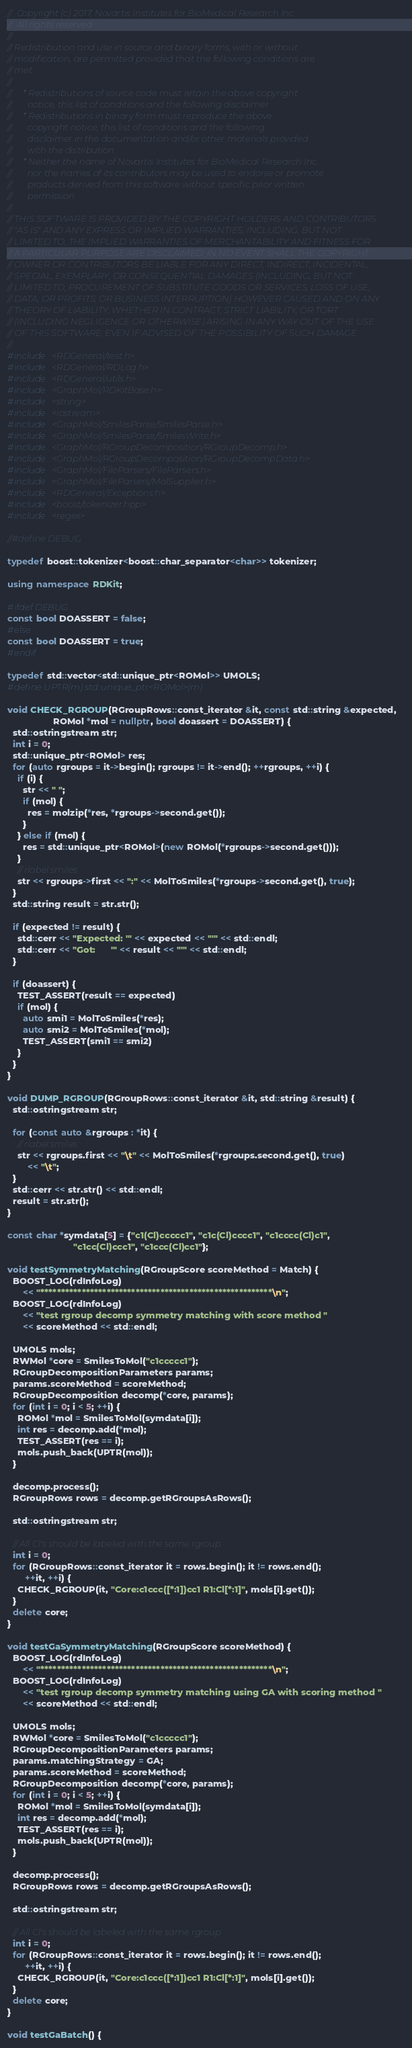Convert code to text. <code><loc_0><loc_0><loc_500><loc_500><_C++_>//  Copyright (c) 2017, Novartis Institutes for BioMedical Research Inc.
//  All rights reserved.
//
// Redistribution and use in source and binary forms, with or without
// modification, are permitted provided that the following conditions are
// met:
//
//     * Redistributions of source code must retain the above copyright
//       notice, this list of conditions and the following disclaimer.
//     * Redistributions in binary form must reproduce the above
//       copyright notice, this list of conditions and the following
//       disclaimer in the documentation and/or other materials provided
//       with the distribution.
//     * Neither the name of Novartis Institutes for BioMedical Research Inc.
//       nor the names of its contributors may be used to endorse or promote
//       products derived from this software without specific prior written
//       permission.
//
// THIS SOFTWARE IS PROVIDED BY THE COPYRIGHT HOLDERS AND CONTRIBUTORS
// "AS IS" AND ANY EXPRESS OR IMPLIED WARRANTIES, INCLUDING, BUT NOT
// LIMITED TO, THE IMPLIED WARRANTIES OF MERCHANTABILITY AND FITNESS FOR
// A PARTICULAR PURPOSE ARE DISCLAIMED. IN NO EVENT SHALL THE COPYRIGHT
// OWNER OR CONTRIBUTORS BE LIABLE FOR ANY DIRECT, INDIRECT, INCIDENTAL,
// SPECIAL, EXEMPLARY, OR CONSEQUENTIAL DAMAGES (INCLUDING, BUT NOT
// LIMITED TO, PROCUREMENT OF SUBSTITUTE GOODS OR SERVICES; LOSS OF USE,
// DATA, OR PROFITS; OR BUSINESS INTERRUPTION) HOWEVER CAUSED AND ON ANY
// THEORY OF LIABILITY, WHETHER IN CONTRACT, STRICT LIABILITY, OR TORT
// (INCLUDING NEGLIGENCE OR OTHERWISE) ARISING IN ANY WAY OUT OF THE USE
// OF THIS SOFTWARE, EVEN IF ADVISED OF THE POSSIBILITY OF SUCH DAMAGE.
//
#include <RDGeneral/test.h>
#include <RDGeneral/RDLog.h>
#include <RDGeneral/utils.h>
#include <GraphMol/RDKitBase.h>
#include <string>
#include <iostream>
#include <GraphMol/SmilesParse/SmilesParse.h>
#include <GraphMol/SmilesParse/SmilesWrite.h>
#include <GraphMol/RGroupDecomposition/RGroupDecomp.h>
#include <GraphMol/RGroupDecomposition/RGroupDecompData.h>
#include <GraphMol/FileParsers/FileParsers.h>
#include <GraphMol/FileParsers/MolSupplier.h>
#include <RDGeneral/Exceptions.h>
#include <boost/tokenizer.hpp>
#include <regex>

//#define DEBUG

typedef boost::tokenizer<boost::char_separator<char>> tokenizer;

using namespace RDKit;

#ifdef DEBUG
const bool DOASSERT = false;
#else
const bool DOASSERT = true;
#endif

typedef std::vector<std::unique_ptr<ROMol>> UMOLS;
#define UPTR(m) std::unique_ptr<ROMol>(m)

void CHECK_RGROUP(RGroupRows::const_iterator &it, const std::string &expected,
                  ROMol *mol = nullptr, bool doassert = DOASSERT) {
  std::ostringstream str;
  int i = 0;
  std::unique_ptr<ROMol> res;
  for (auto rgroups = it->begin(); rgroups != it->end(); ++rgroups, ++i) {
    if (i) {
      str << " ";
      if (mol) {
        res = molzip(*res, *rgroups->second.get());
      }
    } else if (mol) {
      res = std::unique_ptr<ROMol>(new ROMol(*rgroups->second.get()));
    }
    // rlabel:smiles
    str << rgroups->first << ":" << MolToSmiles(*rgroups->second.get(), true);
  }
  std::string result = str.str();

  if (expected != result) {
    std::cerr << "Expected: '" << expected << "'" << std::endl;
    std::cerr << "Got:      '" << result << "'" << std::endl;
  }

  if (doassert) {
    TEST_ASSERT(result == expected)
    if (mol) {
      auto smi1 = MolToSmiles(*res);
      auto smi2 = MolToSmiles(*mol);
      TEST_ASSERT(smi1 == smi2)
    }
  }
}

void DUMP_RGROUP(RGroupRows::const_iterator &it, std::string &result) {
  std::ostringstream str;

  for (const auto &rgroups : *it) {
    // rlabel:smiles
    str << rgroups.first << "\t" << MolToSmiles(*rgroups.second.get(), true)
        << "\t";
  }
  std::cerr << str.str() << std::endl;
  result = str.str();
}

const char *symdata[5] = {"c1(Cl)ccccc1", "c1c(Cl)cccc1", "c1cccc(Cl)c1",
                          "c1cc(Cl)ccc1", "c1ccc(Cl)cc1"};

void testSymmetryMatching(RGroupScore scoreMethod = Match) {
  BOOST_LOG(rdInfoLog)
      << "********************************************************\n";
  BOOST_LOG(rdInfoLog)
      << "test rgroup decomp symmetry matching with score method "
      << scoreMethod << std::endl;

  UMOLS mols;
  RWMol *core = SmilesToMol("c1ccccc1");
  RGroupDecompositionParameters params;
  params.scoreMethod = scoreMethod;
  RGroupDecomposition decomp(*core, params);
  for (int i = 0; i < 5; ++i) {
    ROMol *mol = SmilesToMol(symdata[i]);
    int res = decomp.add(*mol);
    TEST_ASSERT(res == i);
    mols.push_back(UPTR(mol));
  }

  decomp.process();
  RGroupRows rows = decomp.getRGroupsAsRows();

  std::ostringstream str;

  // All Cl's should be labeled with the same rgroup
  int i = 0;
  for (RGroupRows::const_iterator it = rows.begin(); it != rows.end();
       ++it, ++i) {
    CHECK_RGROUP(it, "Core:c1ccc([*:1])cc1 R1:Cl[*:1]", mols[i].get());
  }
  delete core;
}

void testGaSymmetryMatching(RGroupScore scoreMethod) {
  BOOST_LOG(rdInfoLog)
      << "********************************************************\n";
  BOOST_LOG(rdInfoLog)
      << "test rgroup decomp symmetry matching using GA with scoring method "
      << scoreMethod << std::endl;

  UMOLS mols;
  RWMol *core = SmilesToMol("c1ccccc1");
  RGroupDecompositionParameters params;
  params.matchingStrategy = GA;
  params.scoreMethod = scoreMethod;
  RGroupDecomposition decomp(*core, params);
  for (int i = 0; i < 5; ++i) {
    ROMol *mol = SmilesToMol(symdata[i]);
    int res = decomp.add(*mol);
    TEST_ASSERT(res == i);
    mols.push_back(UPTR(mol));
  }

  decomp.process();
  RGroupRows rows = decomp.getRGroupsAsRows();

  std::ostringstream str;

  // All Cl's should be labeled with the same rgroup
  int i = 0;
  for (RGroupRows::const_iterator it = rows.begin(); it != rows.end();
       ++it, ++i) {
    CHECK_RGROUP(it, "Core:c1ccc([*:1])cc1 R1:Cl[*:1]", mols[i].get());
  }
  delete core;
}

void testGaBatch() {</code> 